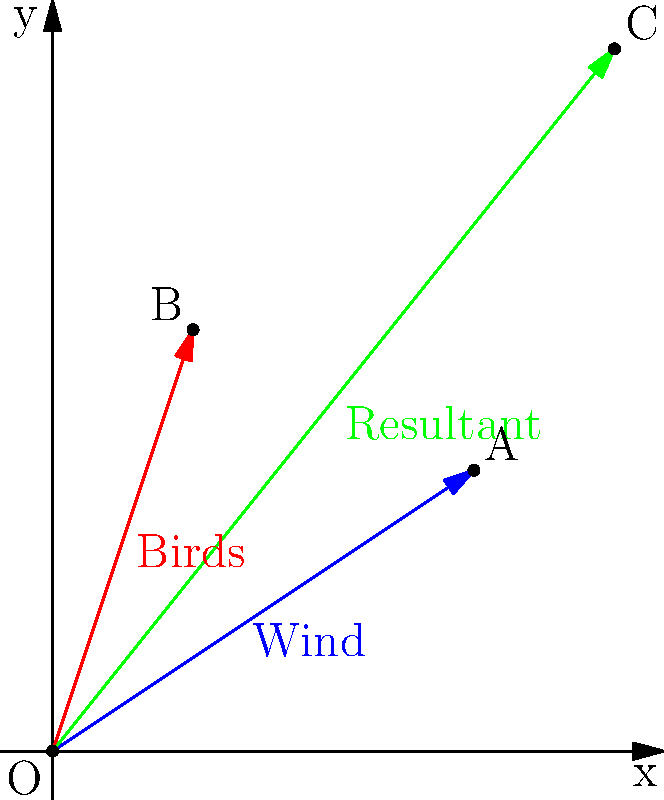The vector diagram illustrates the impact of wind turbines on bird migration patterns. The blue vector represents the wind direction and speed, while the red vector represents the birds' intended flight path. What is the magnitude of the resultant vector (green) representing the actual path of the migrating birds, rounded to the nearest tenth? To find the magnitude of the resultant vector, we need to follow these steps:

1. Identify the components of the wind vector (blue):
   $x_1 = 3$, $y_1 = 2$

2. Identify the components of the birds' intended flight vector (red):
   $x_2 = 1$, $y_2 = 3$

3. Calculate the components of the resultant vector (green) by adding the corresponding components:
   $x_3 = x_1 + x_2 = 3 + 1 = 4$
   $y_3 = y_1 + y_2 = 2 + 3 = 5$

4. Use the Pythagorean theorem to calculate the magnitude of the resultant vector:
   $\text{Magnitude} = \sqrt{x_3^2 + y_3^2}$
   $\text{Magnitude} = \sqrt{4^2 + 5^2}$
   $\text{Magnitude} = \sqrt{16 + 25}$
   $\text{Magnitude} = \sqrt{41}$
   $\text{Magnitude} \approx 6.4$

5. Round the result to the nearest tenth:
   $\text{Magnitude} \approx 6.4$

Therefore, the magnitude of the resultant vector representing the actual path of the migrating birds, rounded to the nearest tenth, is 6.4.
Answer: 6.4 